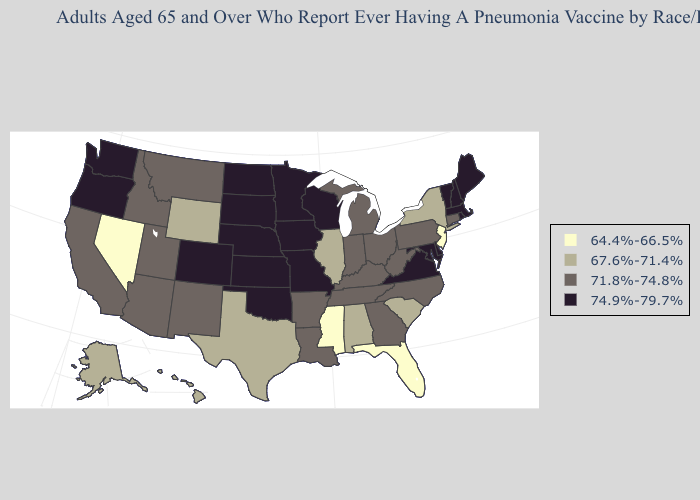Does Alaska have the highest value in the West?
Give a very brief answer. No. Which states have the lowest value in the USA?
Concise answer only. Florida, Mississippi, Nevada, New Jersey. Does Mississippi have the highest value in the South?
Quick response, please. No. Does the map have missing data?
Answer briefly. No. Name the states that have a value in the range 74.9%-79.7%?
Give a very brief answer. Colorado, Delaware, Iowa, Kansas, Maine, Maryland, Massachusetts, Minnesota, Missouri, Nebraska, New Hampshire, North Dakota, Oklahoma, Oregon, Rhode Island, South Dakota, Vermont, Virginia, Washington, Wisconsin. What is the value of Alabama?
Quick response, please. 67.6%-71.4%. What is the value of South Carolina?
Answer briefly. 67.6%-71.4%. Which states have the lowest value in the USA?
Concise answer only. Florida, Mississippi, Nevada, New Jersey. Among the states that border Nevada , which have the lowest value?
Quick response, please. Arizona, California, Idaho, Utah. Name the states that have a value in the range 64.4%-66.5%?
Concise answer only. Florida, Mississippi, Nevada, New Jersey. Does Colorado have the highest value in the West?
Keep it brief. Yes. Name the states that have a value in the range 67.6%-71.4%?
Answer briefly. Alabama, Alaska, Hawaii, Illinois, New York, South Carolina, Texas, Wyoming. Which states have the highest value in the USA?
Short answer required. Colorado, Delaware, Iowa, Kansas, Maine, Maryland, Massachusetts, Minnesota, Missouri, Nebraska, New Hampshire, North Dakota, Oklahoma, Oregon, Rhode Island, South Dakota, Vermont, Virginia, Washington, Wisconsin. What is the highest value in the Northeast ?
Concise answer only. 74.9%-79.7%. What is the value of Michigan?
Keep it brief. 71.8%-74.8%. 